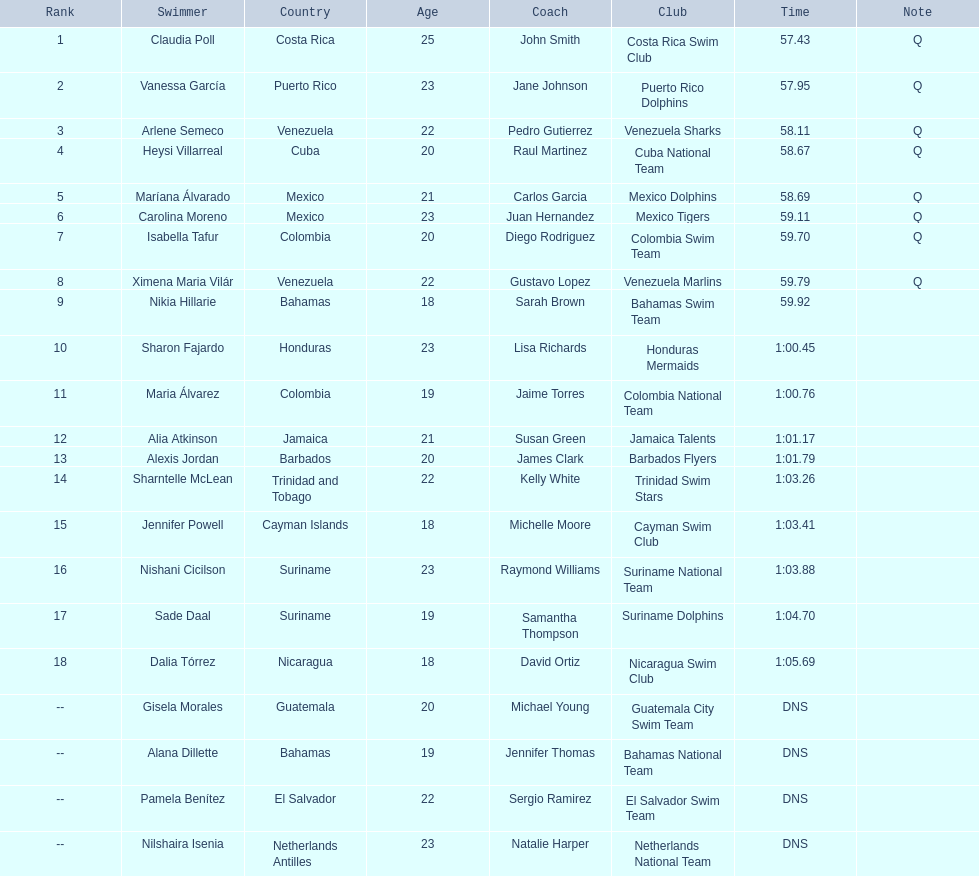Where were the top eight finishers from? Costa Rica, Puerto Rico, Venezuela, Cuba, Mexico, Mexico, Colombia, Venezuela. Which of the top eight were from cuba? Heysi Villarreal. 